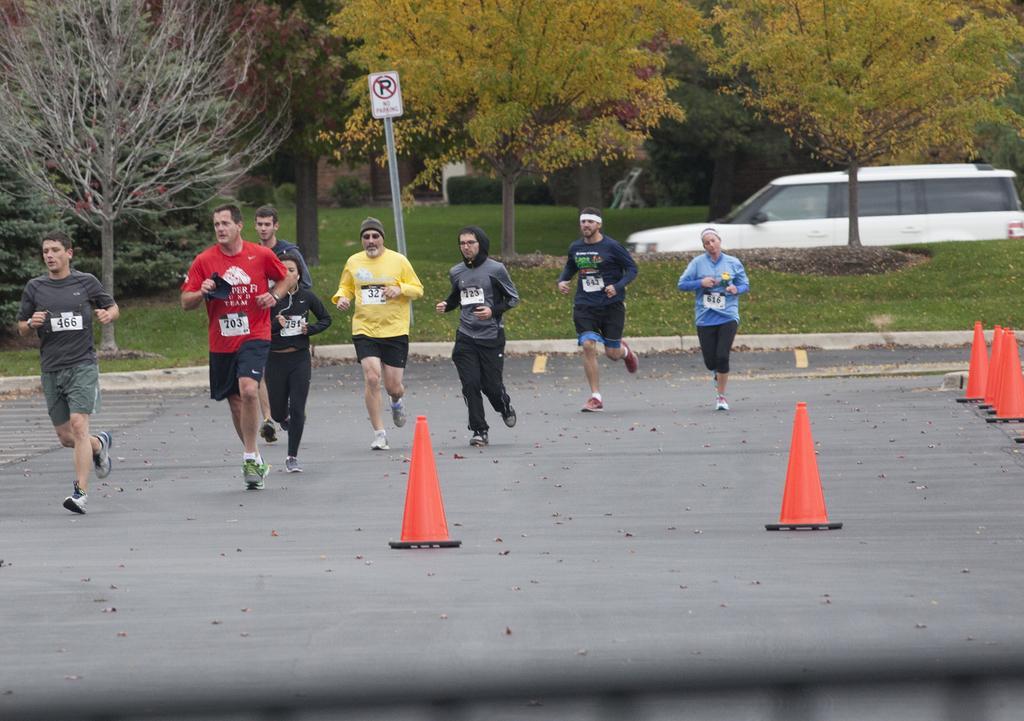Could you give a brief overview of what you see in this image? In this image I can see a group of people jogging on the road with some barricades, I can see the trees at the top of the image. I can see a pole board with some text. I can see a car on the right side of the image. 